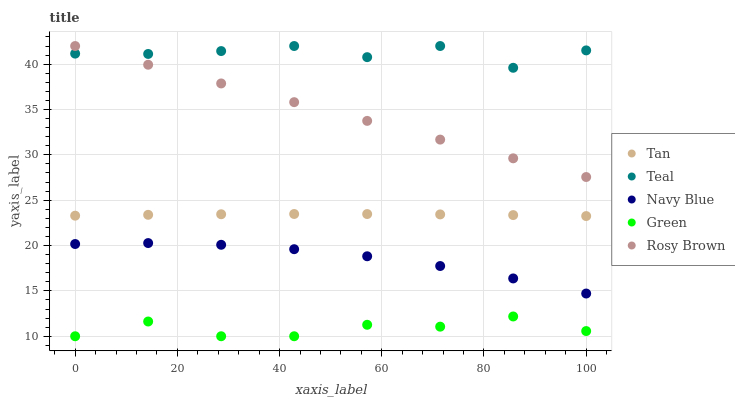Does Green have the minimum area under the curve?
Answer yes or no. Yes. Does Teal have the maximum area under the curve?
Answer yes or no. Yes. Does Tan have the minimum area under the curve?
Answer yes or no. No. Does Tan have the maximum area under the curve?
Answer yes or no. No. Is Rosy Brown the smoothest?
Answer yes or no. Yes. Is Teal the roughest?
Answer yes or no. Yes. Is Tan the smoothest?
Answer yes or no. No. Is Tan the roughest?
Answer yes or no. No. Does Green have the lowest value?
Answer yes or no. Yes. Does Tan have the lowest value?
Answer yes or no. No. Does Teal have the highest value?
Answer yes or no. Yes. Does Tan have the highest value?
Answer yes or no. No. Is Navy Blue less than Rosy Brown?
Answer yes or no. Yes. Is Teal greater than Green?
Answer yes or no. Yes. Does Teal intersect Rosy Brown?
Answer yes or no. Yes. Is Teal less than Rosy Brown?
Answer yes or no. No. Is Teal greater than Rosy Brown?
Answer yes or no. No. Does Navy Blue intersect Rosy Brown?
Answer yes or no. No. 